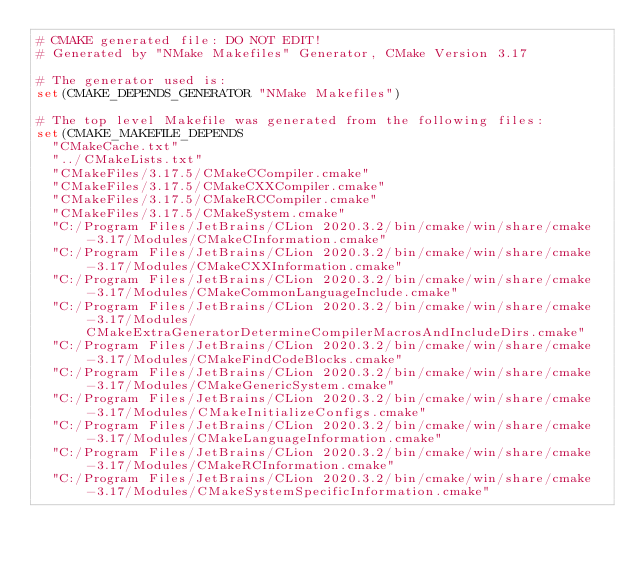Convert code to text. <code><loc_0><loc_0><loc_500><loc_500><_CMake_># CMAKE generated file: DO NOT EDIT!
# Generated by "NMake Makefiles" Generator, CMake Version 3.17

# The generator used is:
set(CMAKE_DEPENDS_GENERATOR "NMake Makefiles")

# The top level Makefile was generated from the following files:
set(CMAKE_MAKEFILE_DEPENDS
  "CMakeCache.txt"
  "../CMakeLists.txt"
  "CMakeFiles/3.17.5/CMakeCCompiler.cmake"
  "CMakeFiles/3.17.5/CMakeCXXCompiler.cmake"
  "CMakeFiles/3.17.5/CMakeRCCompiler.cmake"
  "CMakeFiles/3.17.5/CMakeSystem.cmake"
  "C:/Program Files/JetBrains/CLion 2020.3.2/bin/cmake/win/share/cmake-3.17/Modules/CMakeCInformation.cmake"
  "C:/Program Files/JetBrains/CLion 2020.3.2/bin/cmake/win/share/cmake-3.17/Modules/CMakeCXXInformation.cmake"
  "C:/Program Files/JetBrains/CLion 2020.3.2/bin/cmake/win/share/cmake-3.17/Modules/CMakeCommonLanguageInclude.cmake"
  "C:/Program Files/JetBrains/CLion 2020.3.2/bin/cmake/win/share/cmake-3.17/Modules/CMakeExtraGeneratorDetermineCompilerMacrosAndIncludeDirs.cmake"
  "C:/Program Files/JetBrains/CLion 2020.3.2/bin/cmake/win/share/cmake-3.17/Modules/CMakeFindCodeBlocks.cmake"
  "C:/Program Files/JetBrains/CLion 2020.3.2/bin/cmake/win/share/cmake-3.17/Modules/CMakeGenericSystem.cmake"
  "C:/Program Files/JetBrains/CLion 2020.3.2/bin/cmake/win/share/cmake-3.17/Modules/CMakeInitializeConfigs.cmake"
  "C:/Program Files/JetBrains/CLion 2020.3.2/bin/cmake/win/share/cmake-3.17/Modules/CMakeLanguageInformation.cmake"
  "C:/Program Files/JetBrains/CLion 2020.3.2/bin/cmake/win/share/cmake-3.17/Modules/CMakeRCInformation.cmake"
  "C:/Program Files/JetBrains/CLion 2020.3.2/bin/cmake/win/share/cmake-3.17/Modules/CMakeSystemSpecificInformation.cmake"</code> 